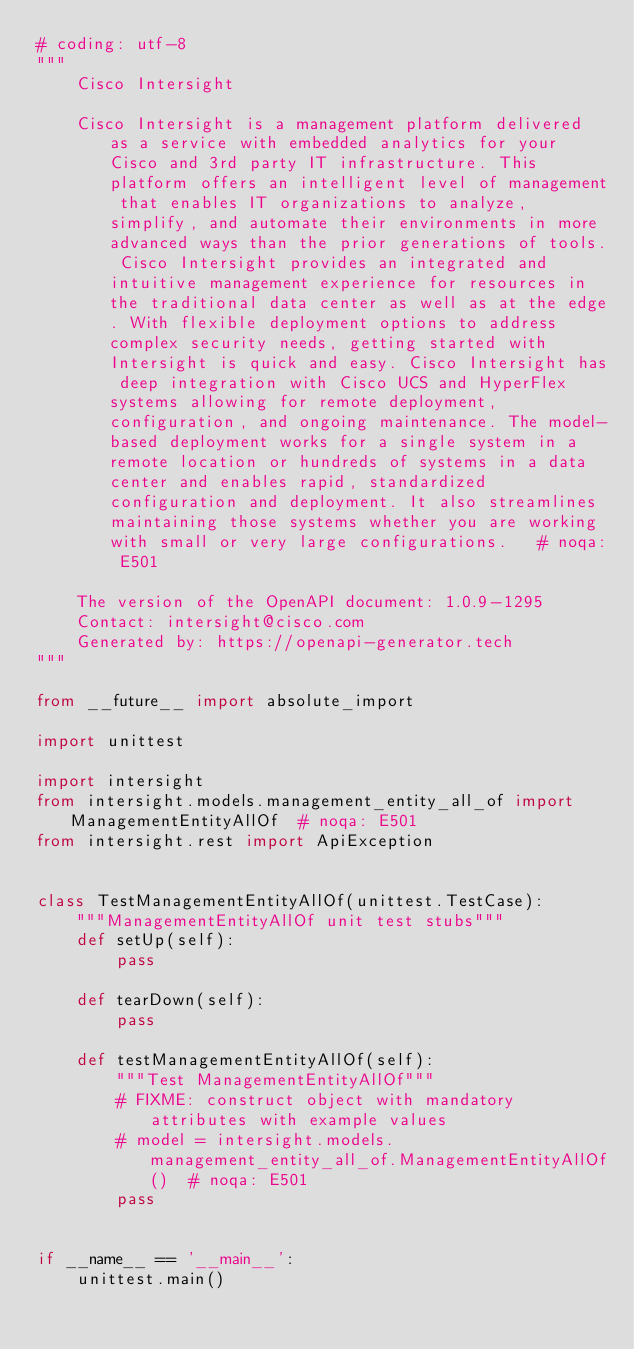Convert code to text. <code><loc_0><loc_0><loc_500><loc_500><_Python_># coding: utf-8
"""
    Cisco Intersight

    Cisco Intersight is a management platform delivered as a service with embedded analytics for your Cisco and 3rd party IT infrastructure. This platform offers an intelligent level of management that enables IT organizations to analyze, simplify, and automate their environments in more advanced ways than the prior generations of tools. Cisco Intersight provides an integrated and intuitive management experience for resources in the traditional data center as well as at the edge. With flexible deployment options to address complex security needs, getting started with Intersight is quick and easy. Cisco Intersight has deep integration with Cisco UCS and HyperFlex systems allowing for remote deployment, configuration, and ongoing maintenance. The model-based deployment works for a single system in a remote location or hundreds of systems in a data center and enables rapid, standardized configuration and deployment. It also streamlines maintaining those systems whether you are working with small or very large configurations.   # noqa: E501

    The version of the OpenAPI document: 1.0.9-1295
    Contact: intersight@cisco.com
    Generated by: https://openapi-generator.tech
"""

from __future__ import absolute_import

import unittest

import intersight
from intersight.models.management_entity_all_of import ManagementEntityAllOf  # noqa: E501
from intersight.rest import ApiException


class TestManagementEntityAllOf(unittest.TestCase):
    """ManagementEntityAllOf unit test stubs"""
    def setUp(self):
        pass

    def tearDown(self):
        pass

    def testManagementEntityAllOf(self):
        """Test ManagementEntityAllOf"""
        # FIXME: construct object with mandatory attributes with example values
        # model = intersight.models.management_entity_all_of.ManagementEntityAllOf()  # noqa: E501
        pass


if __name__ == '__main__':
    unittest.main()
</code> 